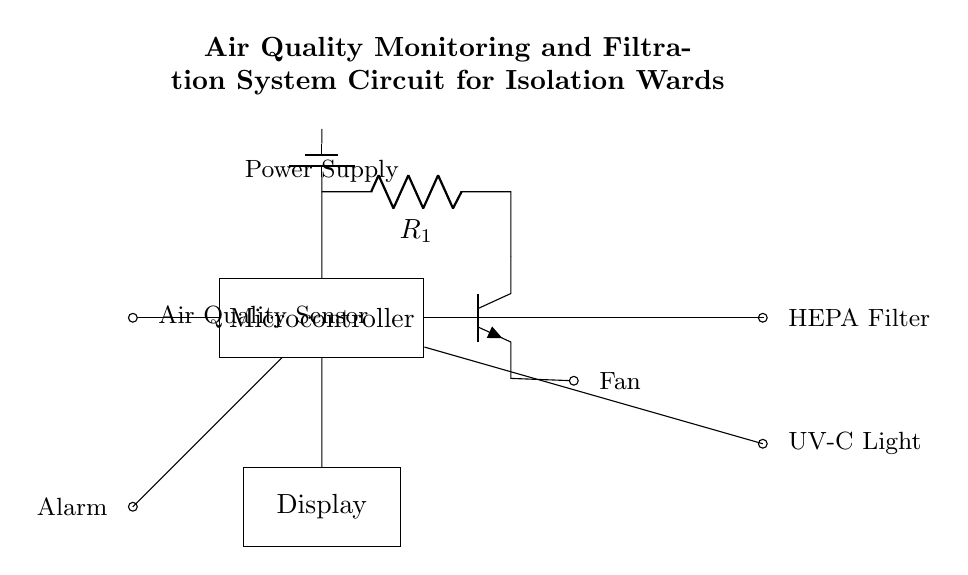What components are in the circuit? The circuit consists of an air quality sensor, microcontroller, fan, HEPA filter, UV-C light, a power supply, a display, and an alarm. Each component has a specific role in monitoring and improving air quality.
Answer: air quality sensor, microcontroller, fan, HEPA filter, UV-C light, power supply, display, alarm What is the role of the fan in this circuit? The fan helps to circulate air through the system, ensuring that contaminants are filtered by the HEPA filter and exposed to the UV-C light for disinfection. This is critical for maintaining a safe air quality in isolation wards.
Answer: circulate air Which component detects the air quality? The air quality sensor is responsible for detecting the levels of pollutants or pathogens in the air. It sends this information to the microcontroller for processing.
Answer: air quality sensor How does the microcontroller communicate with the fan? The microcontroller controls the fan via a transistor (Q1) which regulates the power supplied to the fan based on the signals received from the air quality sensor. This allows for automatic adjustment of fan speed or operation.
Answer: through a transistor What happens to the air after it passes through the HEPA filter? After passing through the HEPA filter, the air is then further treated by the UV-C light. This dual filtration process ensures that airborne contaminants are effectively removed and neutralized before the air is returned to the ward.
Answer: treated by UV-C light What type of alarm is present in the circuit? The alarm is an audible alert that activates when the air quality sensor detects hazardous air quality levels, prompting immediate action to improve the air environment in the isolation ward.
Answer: audible alert 